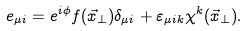<formula> <loc_0><loc_0><loc_500><loc_500>e _ { \mu i } = e ^ { i \phi } f ( \vec { x } _ { \perp } ) \delta _ { \mu i } + \varepsilon _ { \mu i k } \chi ^ { k } ( \vec { x } _ { \perp } ) .</formula> 